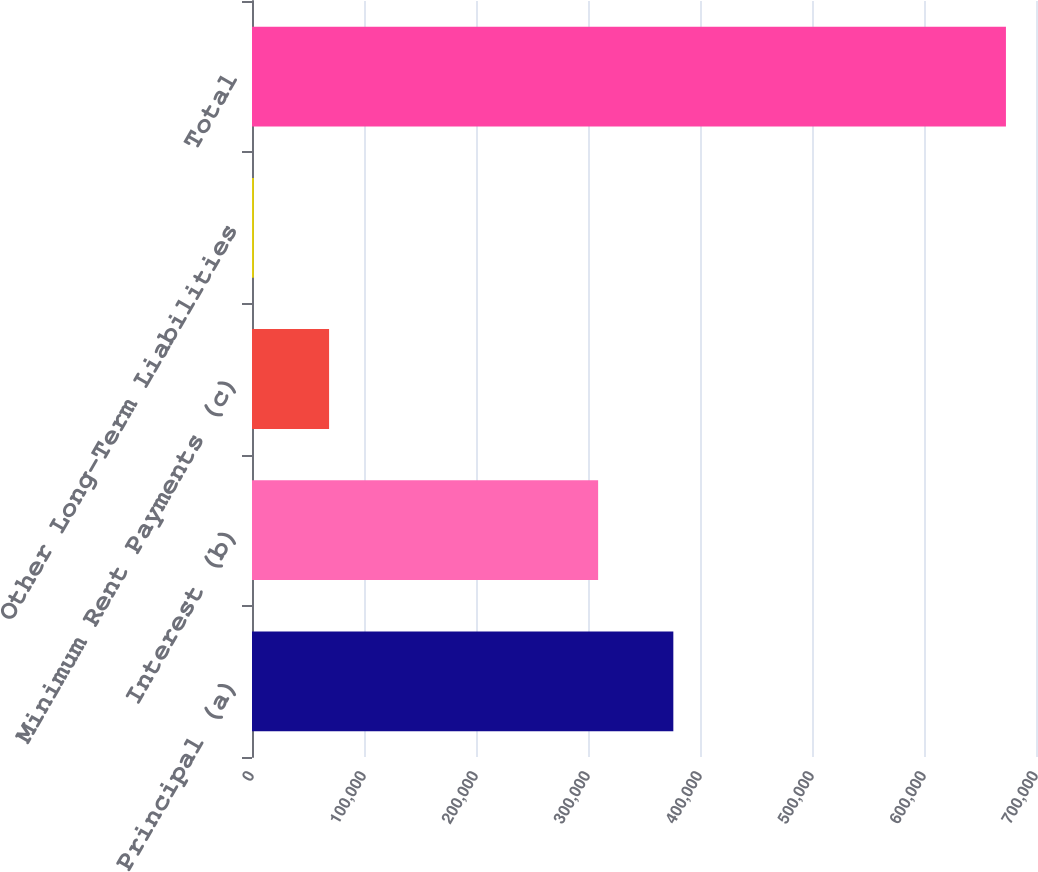Convert chart to OTSL. <chart><loc_0><loc_0><loc_500><loc_500><bar_chart><fcel>Principal (a)<fcel>Interest (b)<fcel>Minimum Rent Payments (c)<fcel>Other Long-Term Liabilities<fcel>Total<nl><fcel>376192<fcel>309043<fcel>68825.5<fcel>1677<fcel>673162<nl></chart> 